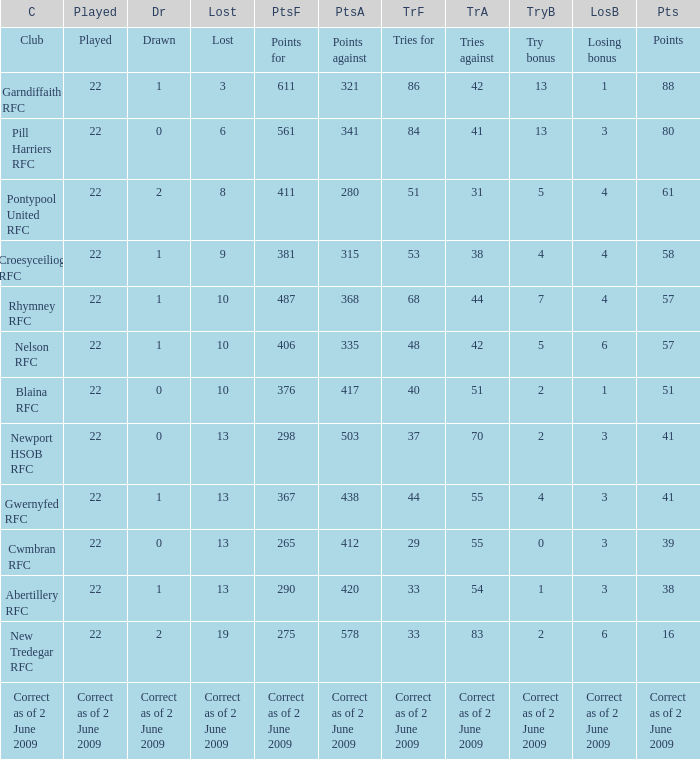Which club has 275 points? New Tredegar RFC. 